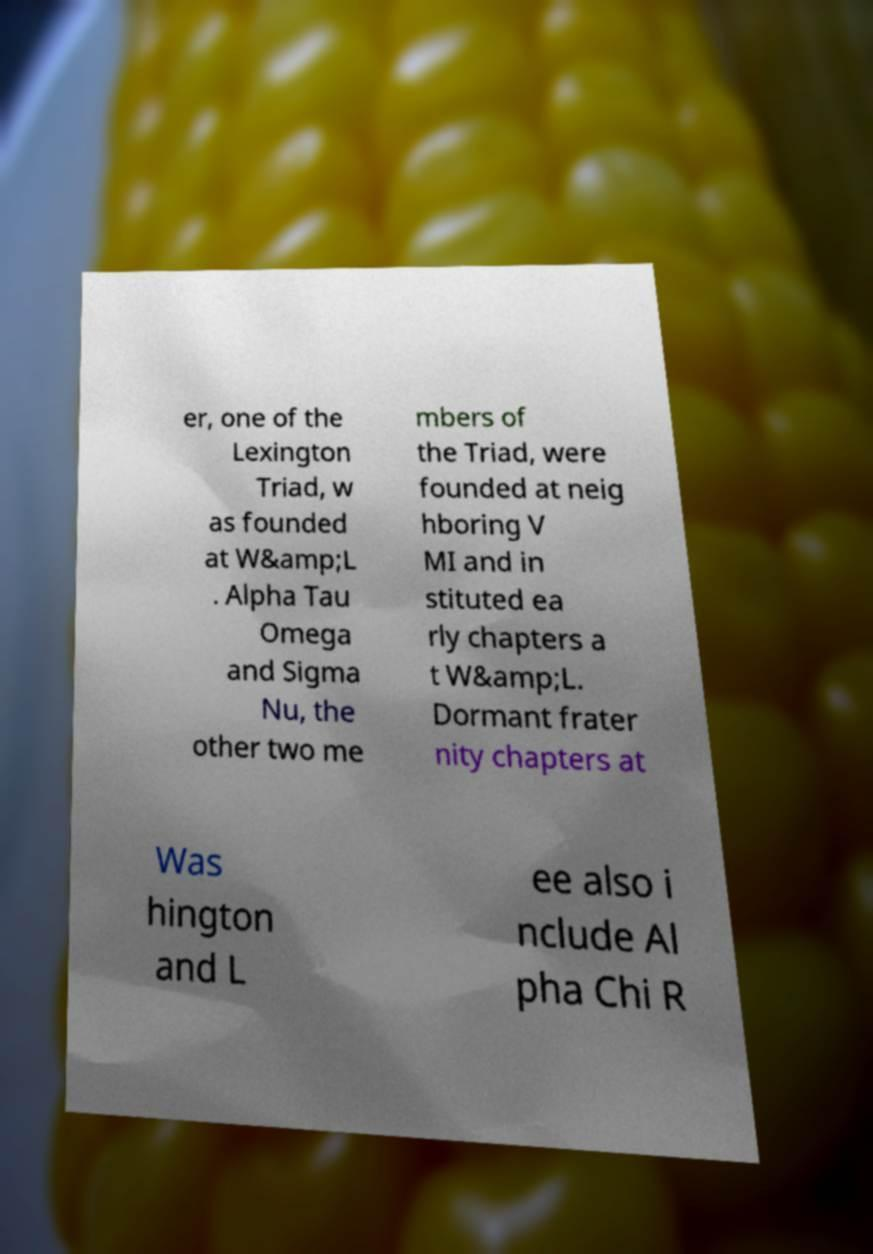Can you accurately transcribe the text from the provided image for me? er, one of the Lexington Triad, w as founded at W&amp;L . Alpha Tau Omega and Sigma Nu, the other two me mbers of the Triad, were founded at neig hboring V MI and in stituted ea rly chapters a t W&amp;L. Dormant frater nity chapters at Was hington and L ee also i nclude Al pha Chi R 